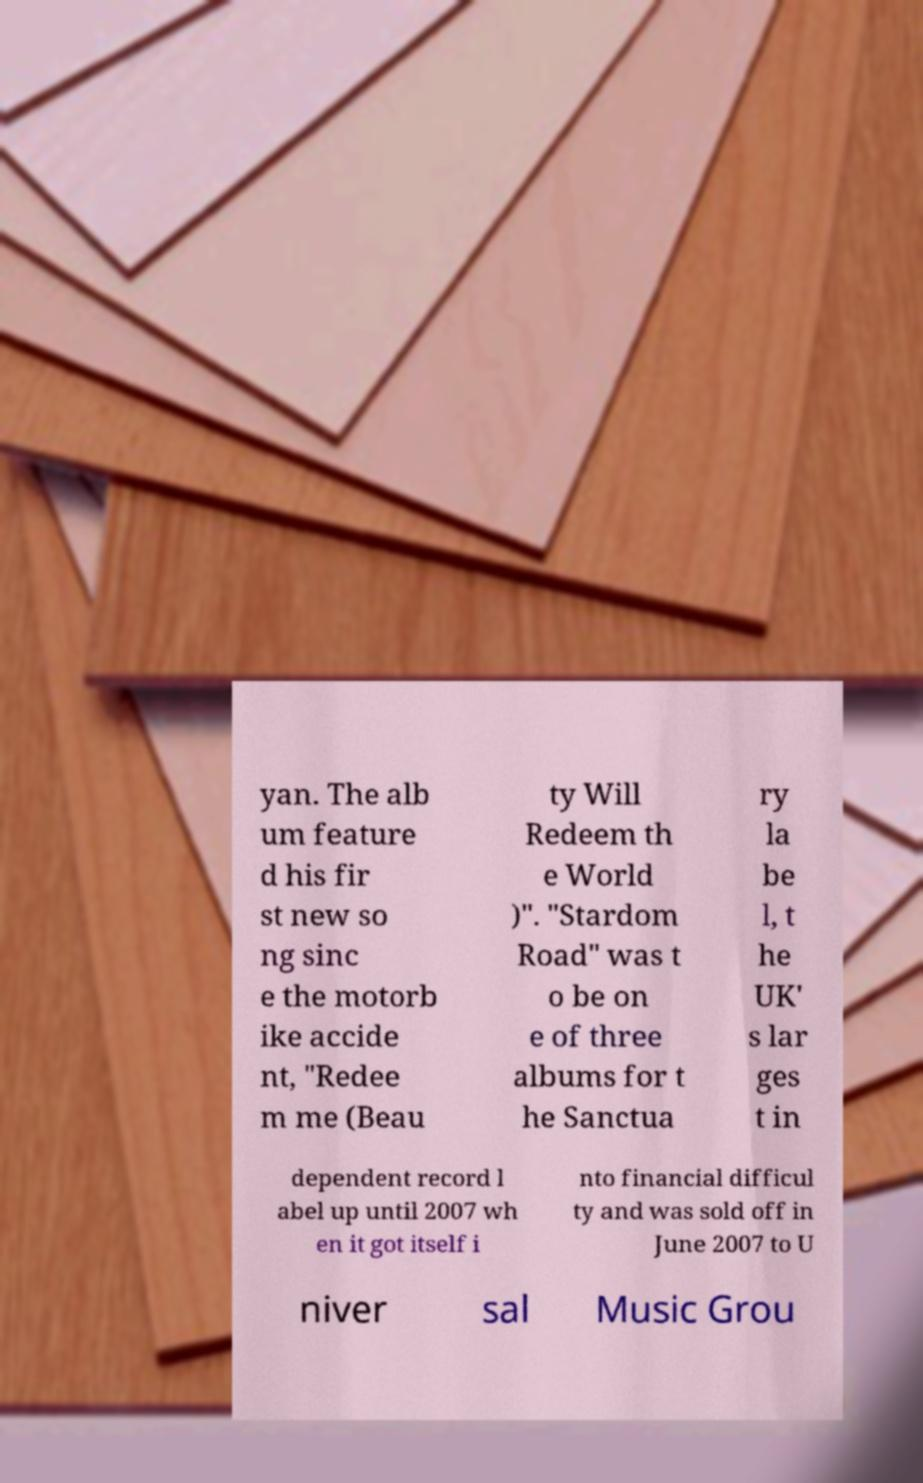For documentation purposes, I need the text within this image transcribed. Could you provide that? yan. The alb um feature d his fir st new so ng sinc e the motorb ike accide nt, "Redee m me (Beau ty Will Redeem th e World )". "Stardom Road" was t o be on e of three albums for t he Sanctua ry la be l, t he UK' s lar ges t in dependent record l abel up until 2007 wh en it got itself i nto financial difficul ty and was sold off in June 2007 to U niver sal Music Grou 